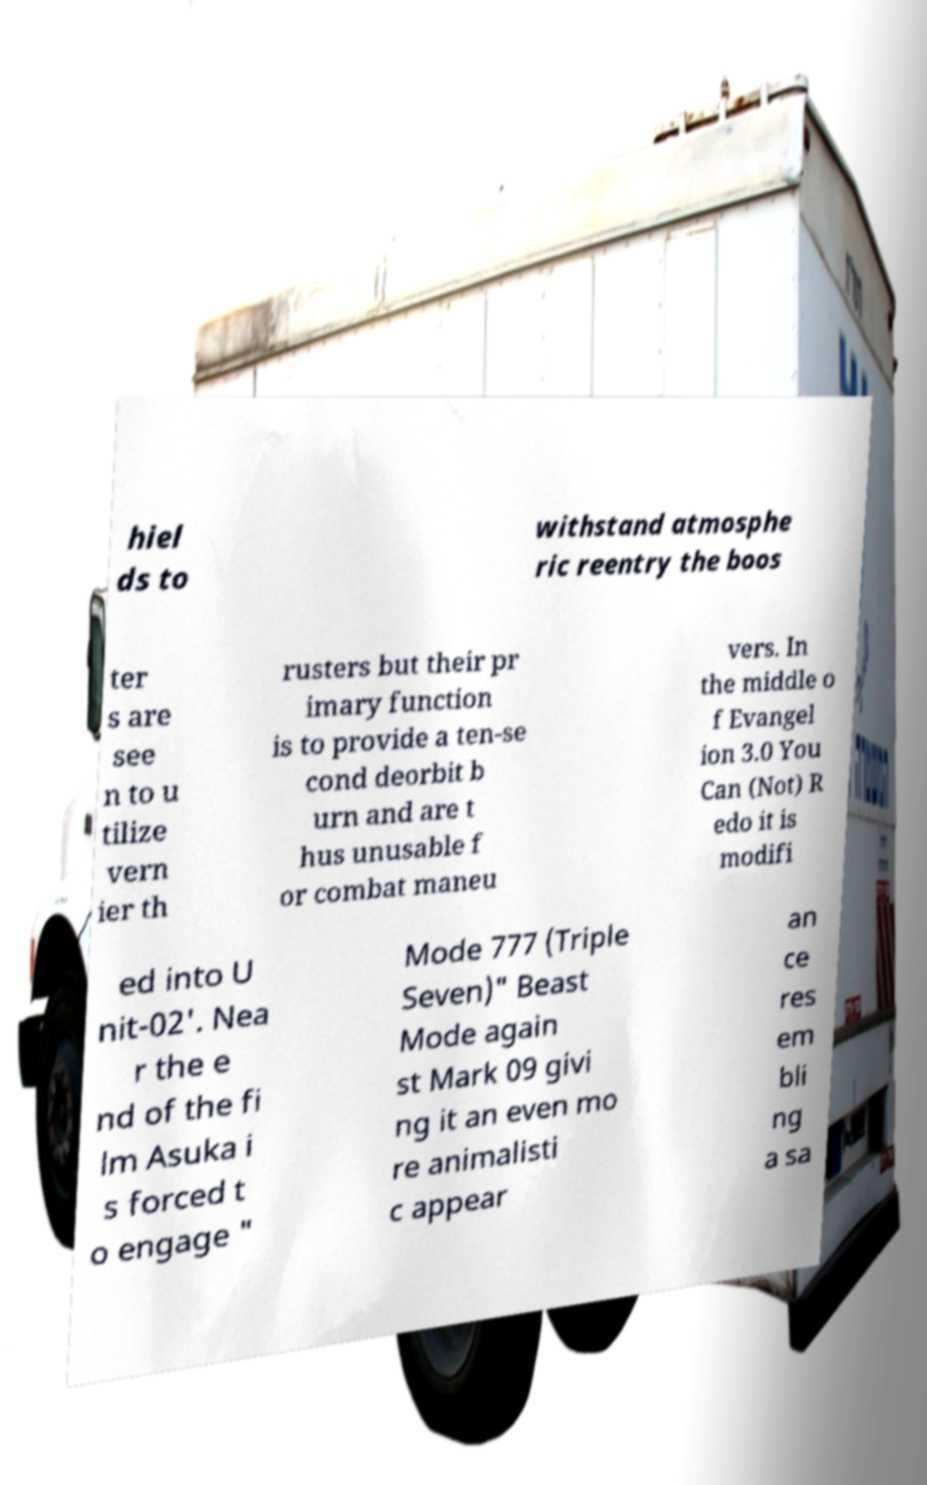Please identify and transcribe the text found in this image. hiel ds to withstand atmosphe ric reentry the boos ter s are see n to u tilize vern ier th rusters but their pr imary function is to provide a ten-se cond deorbit b urn and are t hus unusable f or combat maneu vers. In the middle o f Evangel ion 3.0 You Can (Not) R edo it is modifi ed into U nit-02'. Nea r the e nd of the fi lm Asuka i s forced t o engage " Mode 777 (Triple Seven)" Beast Mode again st Mark 09 givi ng it an even mo re animalisti c appear an ce res em bli ng a sa 